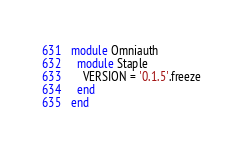Convert code to text. <code><loc_0><loc_0><loc_500><loc_500><_Ruby_>module Omniauth
  module Staple
    VERSION = '0.1.5'.freeze
  end
end
</code> 